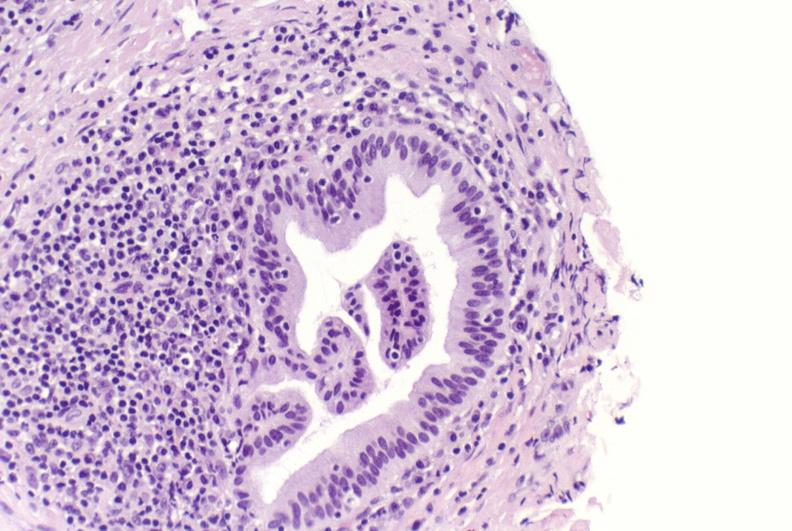s hepatobiliary present?
Answer the question using a single word or phrase. Yes 